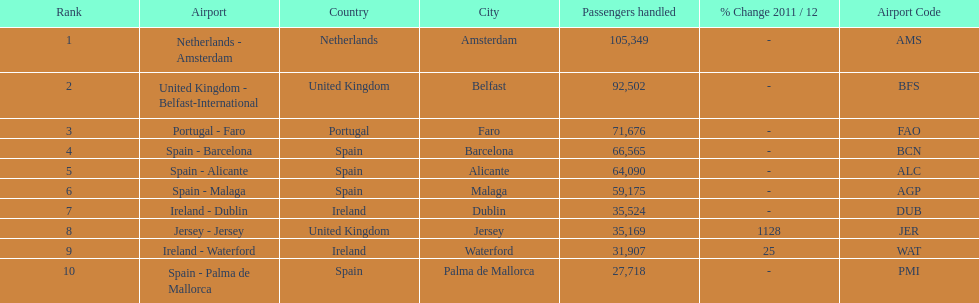Where is the most popular destination for passengers leaving london southend airport? Netherlands - Amsterdam. 